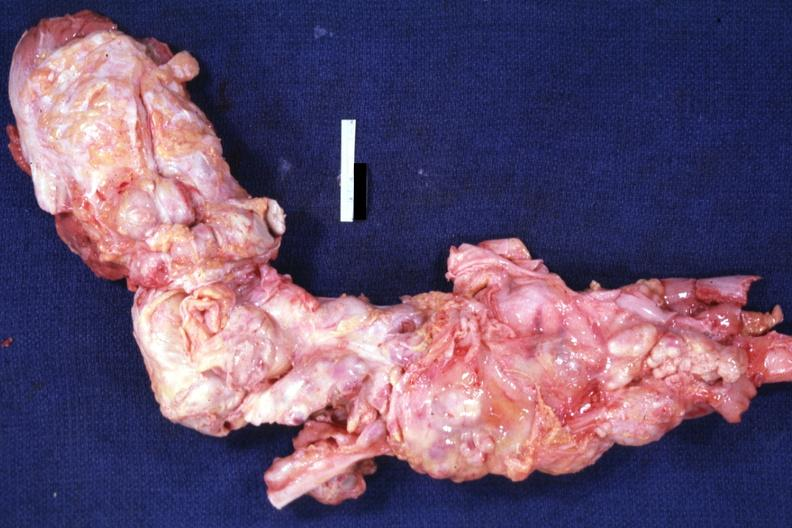what opened surrounded by large nodes?
Answer the question using a single word or phrase. Aorta not 